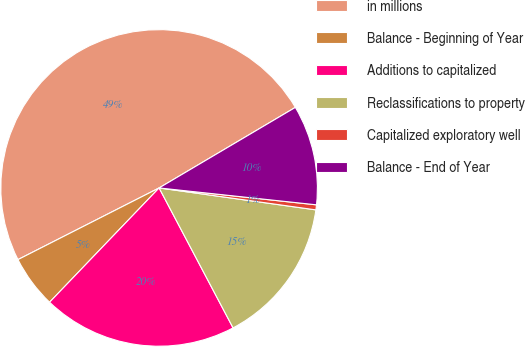Convert chart to OTSL. <chart><loc_0><loc_0><loc_500><loc_500><pie_chart><fcel>in millions<fcel>Balance - Beginning of Year<fcel>Additions to capitalized<fcel>Reclassifications to property<fcel>Capitalized exploratory well<fcel>Balance - End of Year<nl><fcel>48.98%<fcel>5.36%<fcel>19.9%<fcel>15.05%<fcel>0.51%<fcel>10.2%<nl></chart> 